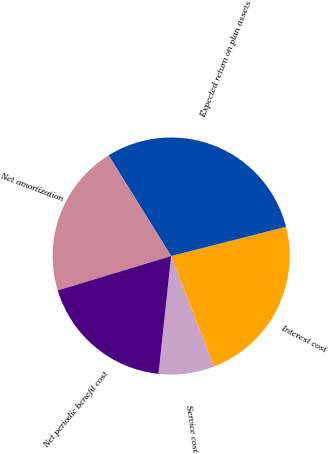Convert chart. <chart><loc_0><loc_0><loc_500><loc_500><pie_chart><fcel>Service cost<fcel>Interest cost<fcel>Expected return on plan assets<fcel>Net amortization<fcel>Net periodic benefit cost<nl><fcel>7.61%<fcel>23.06%<fcel>29.88%<fcel>20.84%<fcel>18.61%<nl></chart> 